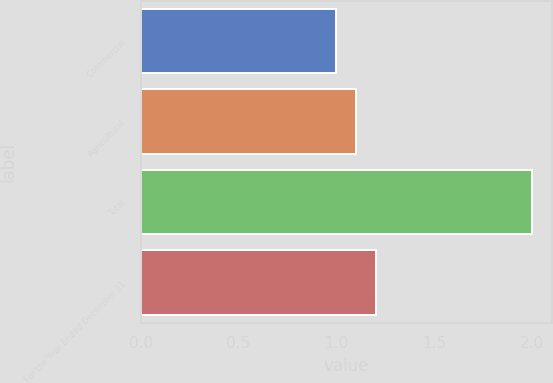<chart> <loc_0><loc_0><loc_500><loc_500><bar_chart><fcel>Commercial<fcel>Agricultural<fcel>Total<fcel>For the Year Ended December 31<nl><fcel>1<fcel>1.1<fcel>2<fcel>1.2<nl></chart> 